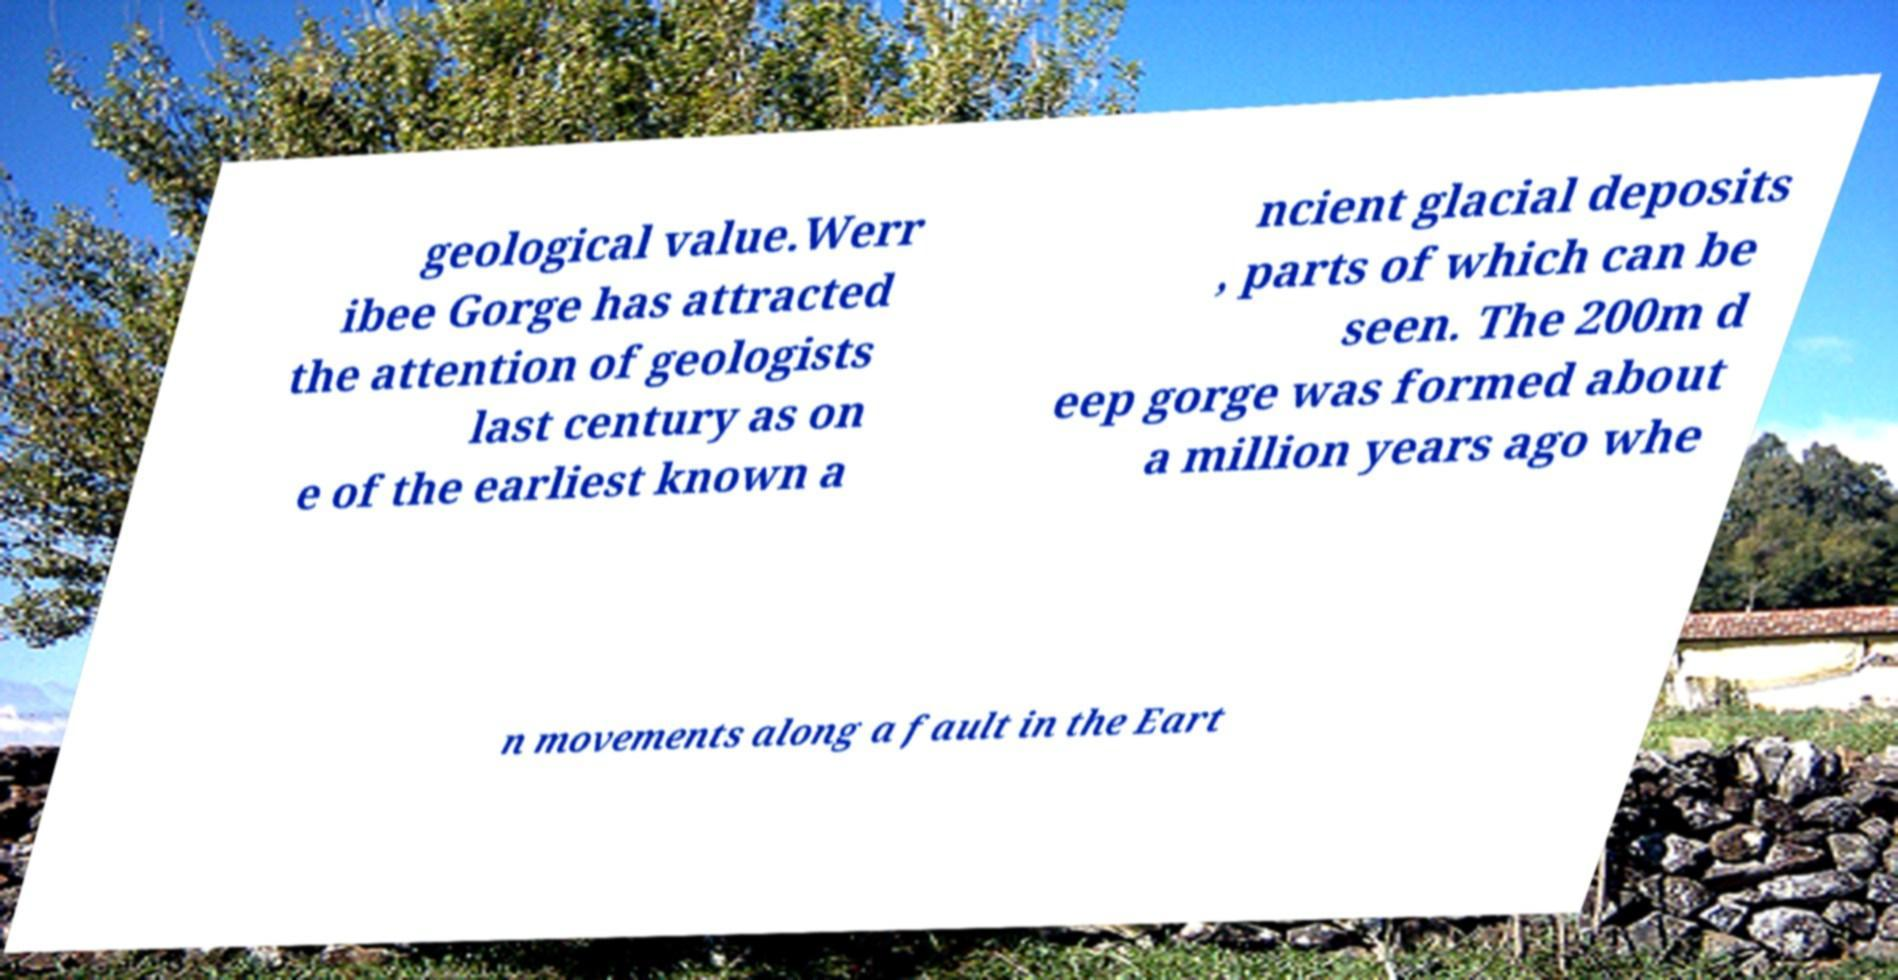Could you extract and type out the text from this image? geological value.Werr ibee Gorge has attracted the attention of geologists last century as on e of the earliest known a ncient glacial deposits , parts of which can be seen. The 200m d eep gorge was formed about a million years ago whe n movements along a fault in the Eart 